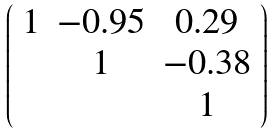<formula> <loc_0><loc_0><loc_500><loc_500>\left ( \begin{array} { c c c } 1 & - 0 . 9 5 & 0 . 2 9 \\ & 1 & - 0 . 3 8 \\ & & 1 \\ \end{array} \right )</formula> 